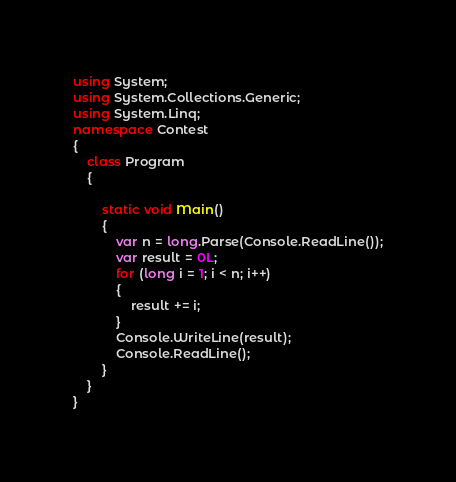Convert code to text. <code><loc_0><loc_0><loc_500><loc_500><_C#_>using System;
using System.Collections.Generic;
using System.Linq;
namespace Contest
{
    class Program
    {

        static void Main()
        {
            var n = long.Parse(Console.ReadLine());
            var result = 0L;
            for (long i = 1; i < n; i++)
            {
                result += i;
            }
            Console.WriteLine(result);
            Console.ReadLine();
        }
    }
}
</code> 